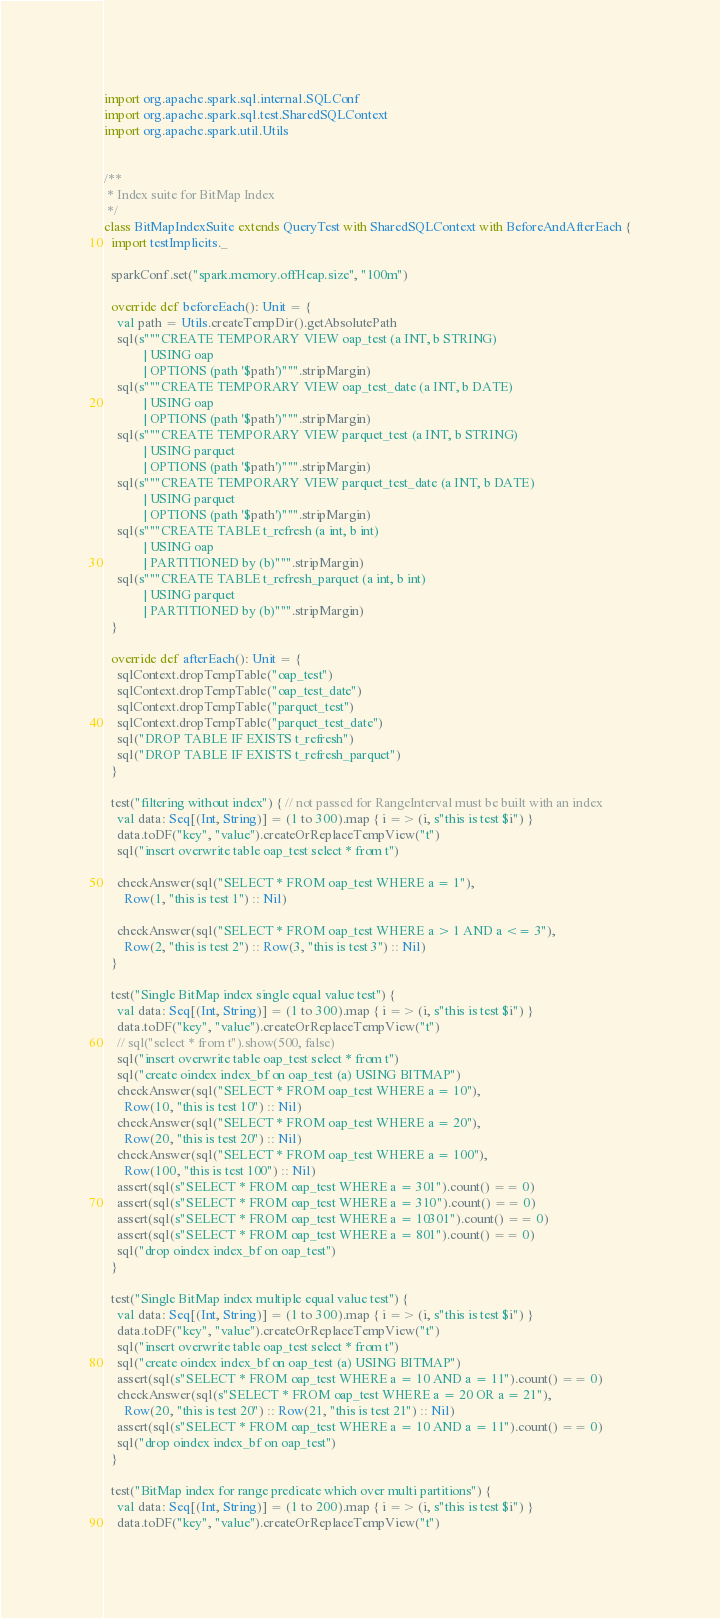<code> <loc_0><loc_0><loc_500><loc_500><_Scala_>import org.apache.spark.sql.internal.SQLConf
import org.apache.spark.sql.test.SharedSQLContext
import org.apache.spark.util.Utils


/**
 * Index suite for BitMap Index
 */
class BitMapIndexSuite extends QueryTest with SharedSQLContext with BeforeAndAfterEach {
  import testImplicits._

  sparkConf.set("spark.memory.offHeap.size", "100m")

  override def beforeEach(): Unit = {
    val path = Utils.createTempDir().getAbsolutePath
    sql(s"""CREATE TEMPORARY VIEW oap_test (a INT, b STRING)
            | USING oap
            | OPTIONS (path '$path')""".stripMargin)
    sql(s"""CREATE TEMPORARY VIEW oap_test_date (a INT, b DATE)
            | USING oap
            | OPTIONS (path '$path')""".stripMargin)
    sql(s"""CREATE TEMPORARY VIEW parquet_test (a INT, b STRING)
            | USING parquet
            | OPTIONS (path '$path')""".stripMargin)
    sql(s"""CREATE TEMPORARY VIEW parquet_test_date (a INT, b DATE)
            | USING parquet
            | OPTIONS (path '$path')""".stripMargin)
    sql(s"""CREATE TABLE t_refresh (a int, b int)
            | USING oap
            | PARTITIONED by (b)""".stripMargin)
    sql(s"""CREATE TABLE t_refresh_parquet (a int, b int)
            | USING parquet
            | PARTITIONED by (b)""".stripMargin)
  }

  override def afterEach(): Unit = {
    sqlContext.dropTempTable("oap_test")
    sqlContext.dropTempTable("oap_test_date")
    sqlContext.dropTempTable("parquet_test")
    sqlContext.dropTempTable("parquet_test_date")
    sql("DROP TABLE IF EXISTS t_refresh")
    sql("DROP TABLE IF EXISTS t_refresh_parquet")
  }

  test("filtering without index") { // not passed for RangeInterval must be built with an index
    val data: Seq[(Int, String)] = (1 to 300).map { i => (i, s"this is test $i") }
    data.toDF("key", "value").createOrReplaceTempView("t")
    sql("insert overwrite table oap_test select * from t")

    checkAnswer(sql("SELECT * FROM oap_test WHERE a = 1"),
      Row(1, "this is test 1") :: Nil)

    checkAnswer(sql("SELECT * FROM oap_test WHERE a > 1 AND a <= 3"),
      Row(2, "this is test 2") :: Row(3, "this is test 3") :: Nil)
  }

  test("Single BitMap index single equal value test") {
    val data: Seq[(Int, String)] = (1 to 300).map { i => (i, s"this is test $i") }
    data.toDF("key", "value").createOrReplaceTempView("t")
    // sql("select * from t").show(500, false)
    sql("insert overwrite table oap_test select * from t")
    sql("create oindex index_bf on oap_test (a) USING BITMAP")
    checkAnswer(sql("SELECT * FROM oap_test WHERE a = 10"),
      Row(10, "this is test 10") :: Nil)
    checkAnswer(sql("SELECT * FROM oap_test WHERE a = 20"),
      Row(20, "this is test 20") :: Nil)
    checkAnswer(sql("SELECT * FROM oap_test WHERE a = 100"),
      Row(100, "this is test 100") :: Nil)
    assert(sql(s"SELECT * FROM oap_test WHERE a = 301").count() == 0)
    assert(sql(s"SELECT * FROM oap_test WHERE a = 310").count() == 0)
    assert(sql(s"SELECT * FROM oap_test WHERE a = 10301").count() == 0)
    assert(sql(s"SELECT * FROM oap_test WHERE a = 801").count() == 0)
    sql("drop oindex index_bf on oap_test")
  }

  test("Single BitMap index multiple equal value test") {
    val data: Seq[(Int, String)] = (1 to 300).map { i => (i, s"this is test $i") }
    data.toDF("key", "value").createOrReplaceTempView("t")
    sql("insert overwrite table oap_test select * from t")
    sql("create oindex index_bf on oap_test (a) USING BITMAP")
    assert(sql(s"SELECT * FROM oap_test WHERE a = 10 AND a = 11").count() == 0)
    checkAnswer(sql(s"SELECT * FROM oap_test WHERE a = 20 OR a = 21"),
      Row(20, "this is test 20") :: Row(21, "this is test 21") :: Nil)
    assert(sql(s"SELECT * FROM oap_test WHERE a = 10 AND a = 11").count() == 0)
    sql("drop oindex index_bf on oap_test")
  }

  test("BitMap index for range predicate which over multi partitions") {
    val data: Seq[(Int, String)] = (1 to 200).map { i => (i, s"this is test $i") }
    data.toDF("key", "value").createOrReplaceTempView("t")</code> 